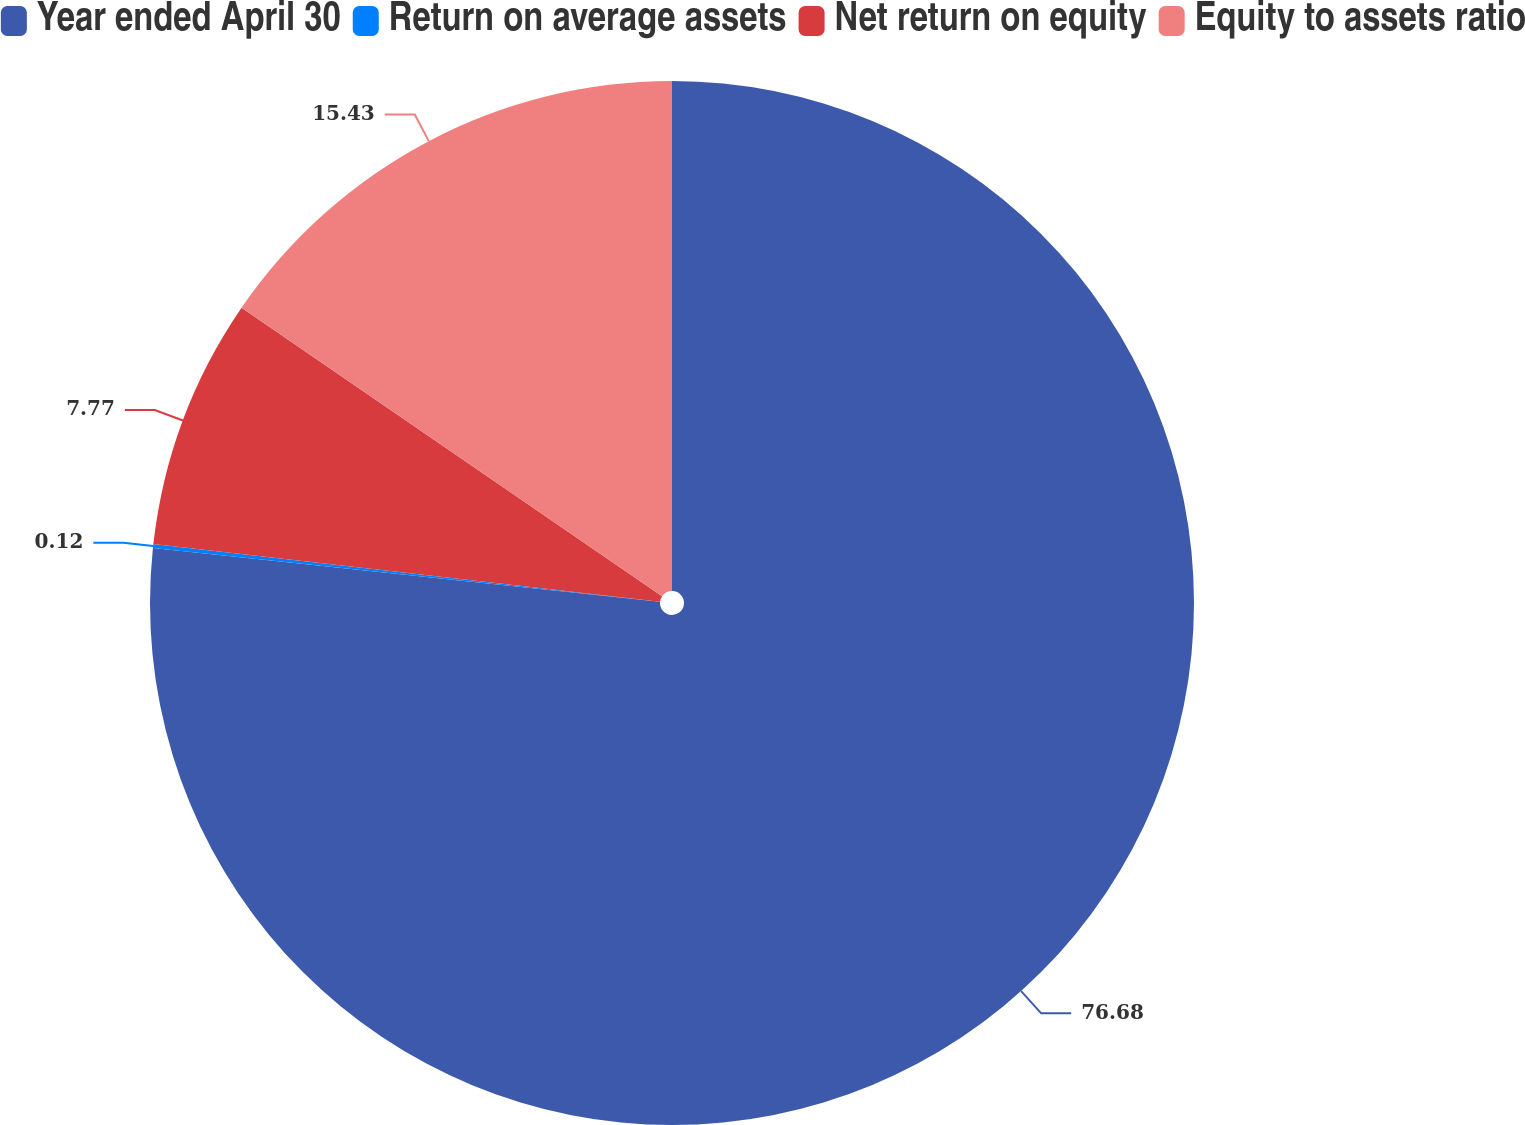Convert chart to OTSL. <chart><loc_0><loc_0><loc_500><loc_500><pie_chart><fcel>Year ended April 30<fcel>Return on average assets<fcel>Net return on equity<fcel>Equity to assets ratio<nl><fcel>76.68%<fcel>0.12%<fcel>7.77%<fcel>15.43%<nl></chart> 